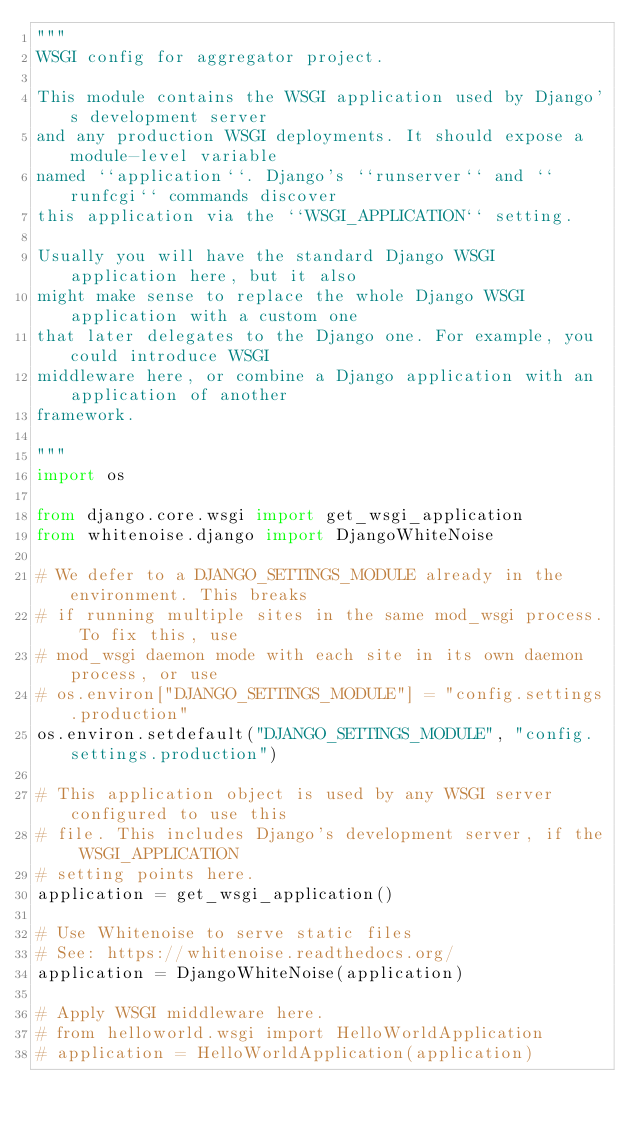Convert code to text. <code><loc_0><loc_0><loc_500><loc_500><_Python_>"""
WSGI config for aggregator project.

This module contains the WSGI application used by Django's development server
and any production WSGI deployments. It should expose a module-level variable
named ``application``. Django's ``runserver`` and ``runfcgi`` commands discover
this application via the ``WSGI_APPLICATION`` setting.

Usually you will have the standard Django WSGI application here, but it also
might make sense to replace the whole Django WSGI application with a custom one
that later delegates to the Django one. For example, you could introduce WSGI
middleware here, or combine a Django application with an application of another
framework.

"""
import os

from django.core.wsgi import get_wsgi_application
from whitenoise.django import DjangoWhiteNoise

# We defer to a DJANGO_SETTINGS_MODULE already in the environment. This breaks
# if running multiple sites in the same mod_wsgi process. To fix this, use
# mod_wsgi daemon mode with each site in its own daemon process, or use
# os.environ["DJANGO_SETTINGS_MODULE"] = "config.settings.production"
os.environ.setdefault("DJANGO_SETTINGS_MODULE", "config.settings.production")

# This application object is used by any WSGI server configured to use this
# file. This includes Django's development server, if the WSGI_APPLICATION
# setting points here.
application = get_wsgi_application()

# Use Whitenoise to serve static files
# See: https://whitenoise.readthedocs.org/
application = DjangoWhiteNoise(application)

# Apply WSGI middleware here.
# from helloworld.wsgi import HelloWorldApplication
# application = HelloWorldApplication(application)
</code> 